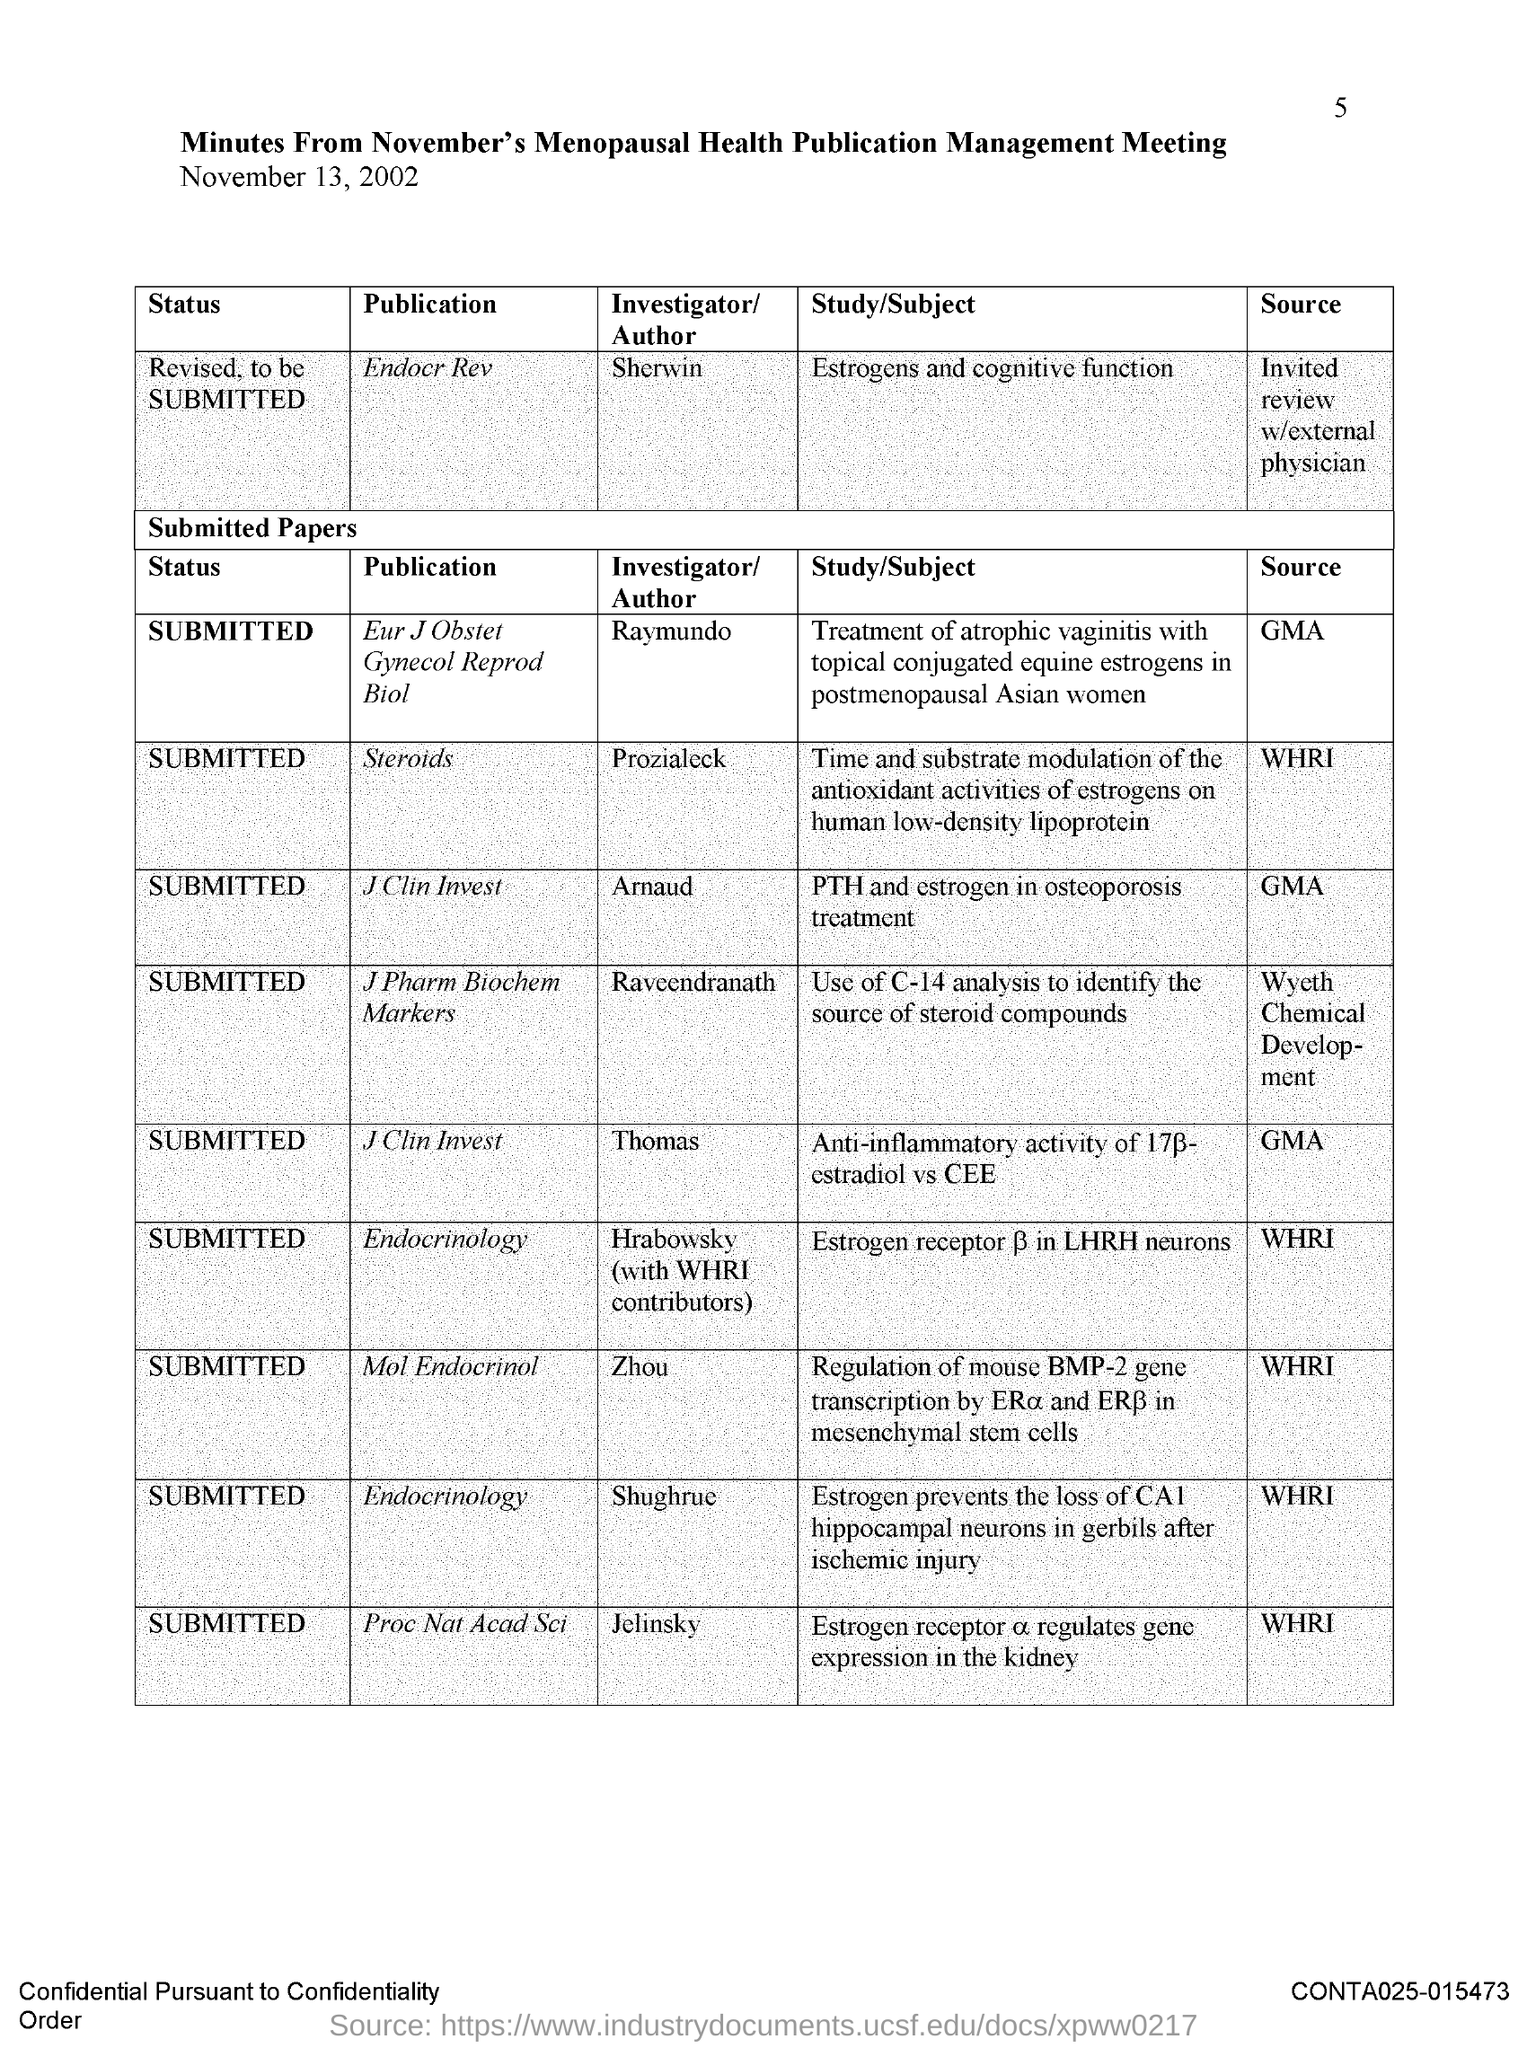What is the page number?
Give a very brief answer. 5. What is the title of the document?
Provide a succinct answer. Minutes from november's menopausal health publication management meeting. Who is the author of the publication "Endocr Rev"?
Make the answer very short. Sherwin. Who is the author of the publication "Steroids"?
Your answer should be compact. Prozialeck. What is the status of the publication "Steroids"?
Make the answer very short. SUBMITTED. Jelinsky is the author of which publication?
Offer a terse response. Proc Nat Acad Sci. Shughrue is the author of which publication?
Provide a succinct answer. Endocrinology. What is the status of the publication "Mol Endocrinol"?
Make the answer very short. Submitted. Who is the author of the publication "Mol Endocrinol"?
Provide a succinct answer. Zhou. Thomas is the author of which publication?
Give a very brief answer. J Clin Invest. 